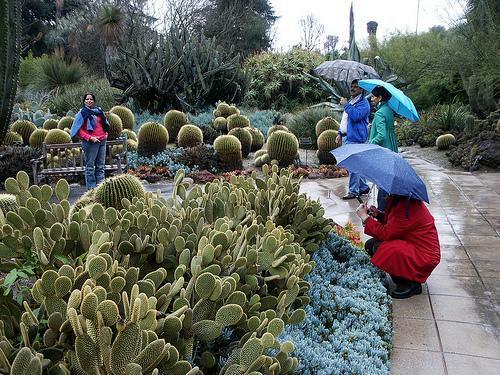How many umbrellas are there?
Give a very brief answer. 3. 